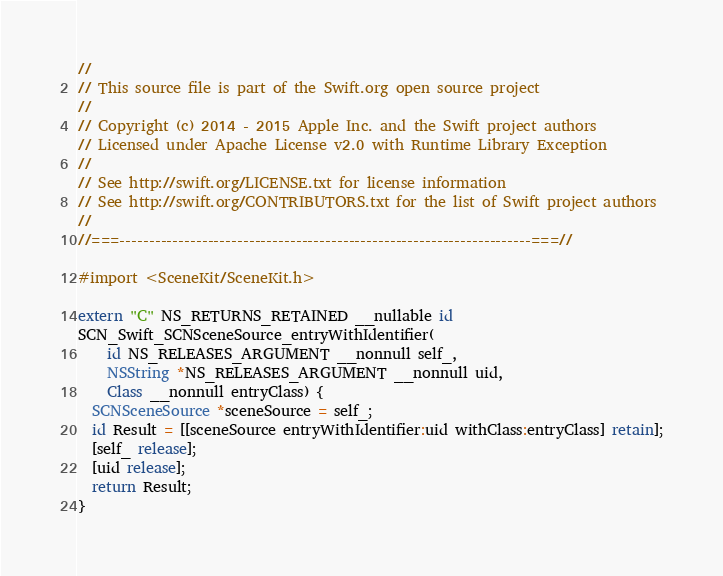Convert code to text. <code><loc_0><loc_0><loc_500><loc_500><_ObjectiveC_>//
// This source file is part of the Swift.org open source project
//
// Copyright (c) 2014 - 2015 Apple Inc. and the Swift project authors
// Licensed under Apache License v2.0 with Runtime Library Exception
//
// See http://swift.org/LICENSE.txt for license information
// See http://swift.org/CONTRIBUTORS.txt for the list of Swift project authors
//
//===----------------------------------------------------------------------===//

#import <SceneKit/SceneKit.h>

extern "C" NS_RETURNS_RETAINED __nullable id
SCN_Swift_SCNSceneSource_entryWithIdentifier(
    id NS_RELEASES_ARGUMENT __nonnull self_,
    NSString *NS_RELEASES_ARGUMENT __nonnull uid,
    Class __nonnull entryClass) {
  SCNSceneSource *sceneSource = self_;
  id Result = [[sceneSource entryWithIdentifier:uid withClass:entryClass] retain];
  [self_ release];
  [uid release];
  return Result;
}

</code> 